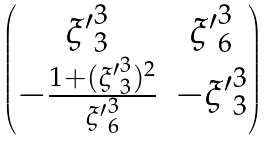Convert formula to latex. <formula><loc_0><loc_0><loc_500><loc_500>\begin{pmatrix} { { \xi ^ { \prime } } ^ { 3 } _ { 3 } } & { { \xi ^ { \prime } } ^ { 3 } _ { 6 } } \\ - \frac { 1 + ( { { \xi ^ { \prime } } ^ { 3 } _ { 3 } } ) ^ { 2 } } { { { \xi ^ { \prime } } ^ { 3 } _ { 6 } } } & - { { \xi ^ { \prime } } ^ { 3 } _ { 3 } } \end{pmatrix}</formula> 